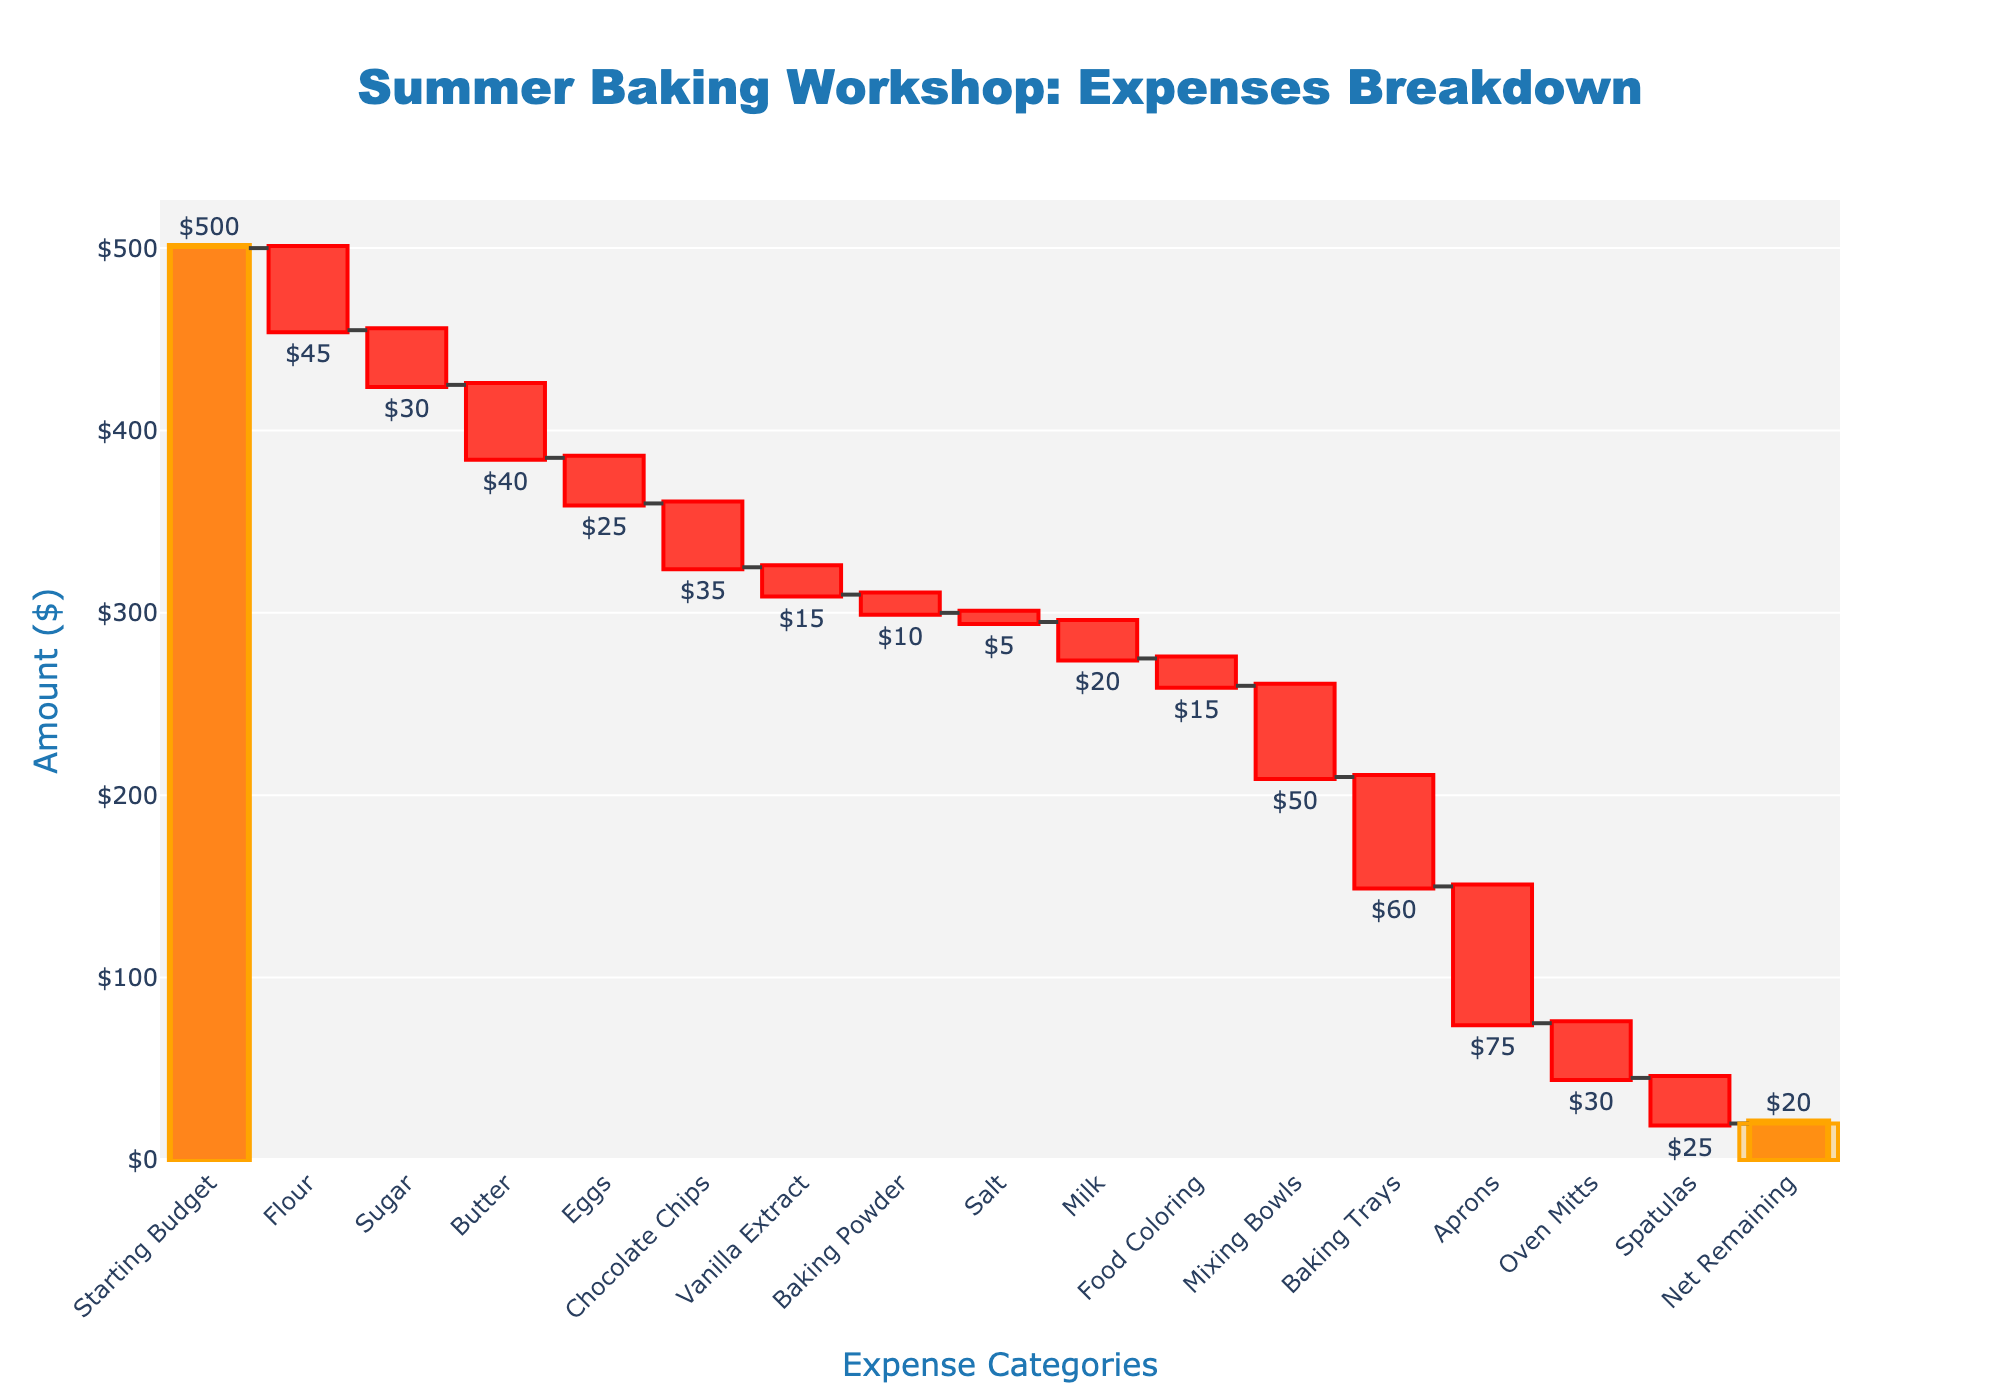What is the title of the waterfall chart? The title of a chart is usually displayed at the top of the figure. In this case, the title reads, "Summer Baking Workshop: Expenses Breakdown".
Answer: Summer Baking Workshop: Expenses Breakdown What is the starting budget for the baking workshop? The starting budget is the initial value shown on the chart, typically the first bar, labeled as "Starting Budget", and it is $500, represented in absolute terms.
Answer: $500 How much total was spent on Flour, Sugar, and Butter? The amounts for Flour, Sugar, and Butter are respectively $45, $30, and $40. Adding these values gives the total expenditure: $45 + $30 + $40 = $115.
Answer: $115 Which items had the highest and lowest individual costs? The chart shows the individual costs for each category as separated bars. The Aprons cost the most ($75), and Salt costs the least ($5).
Answer: Aprons ($75), Salt ($5) What is the cumulative expense after purchasing Flour and Sugar? To get the cumulative expense, you add the costs of Flour and Sugar to the Starting Budget and subtract these from it. The cumulative expense is $500 (Starting Budget) - $45 (Flour) - $30 (Sugar) = $425.
Answer: $425 Which item decreased the budget more: Mixing Bowls or Baking Trays? Comparing the values of Mixing Bowls ($50) and Baking Trays ($60) in the chart, Baking Trays lead to a greater budget decrease.
Answer: Baking Trays How much money is left after all expenses? The chart indicates this directly in the "Net Remaining" category, the last bar, which is shown as $20.
Answer: $20 What is the total amount spent on ingredients alone (excluding equipment)? The ingredients and their costs are: Flour ($45), Sugar ($30), Butter ($40), Eggs ($25), Chocolate Chips ($35), Vanilla Extract ($15), Baking Powder ($10), Salt ($5), and Milk ($20). Summing these up: $45 + $30 + $40 + $25 + $35 + $15 + $10 + $5 + $20 = $225.
Answer: $225 How does the cost of Aprons compare to the total remaining budget? The cost of Aprons is $75, and the total remaining budget is $20. The cost of Aprons is higher than the remaining budget.
Answer: The cost of Aprons is higher than the remaining budget What percentage of the starting budget is left after all expenses? To find the percentage, we use the remaining budget ($20) and the starting budget ($500). The calculation is ($20 / $500) * 100 = 4%.
Answer: 4% 